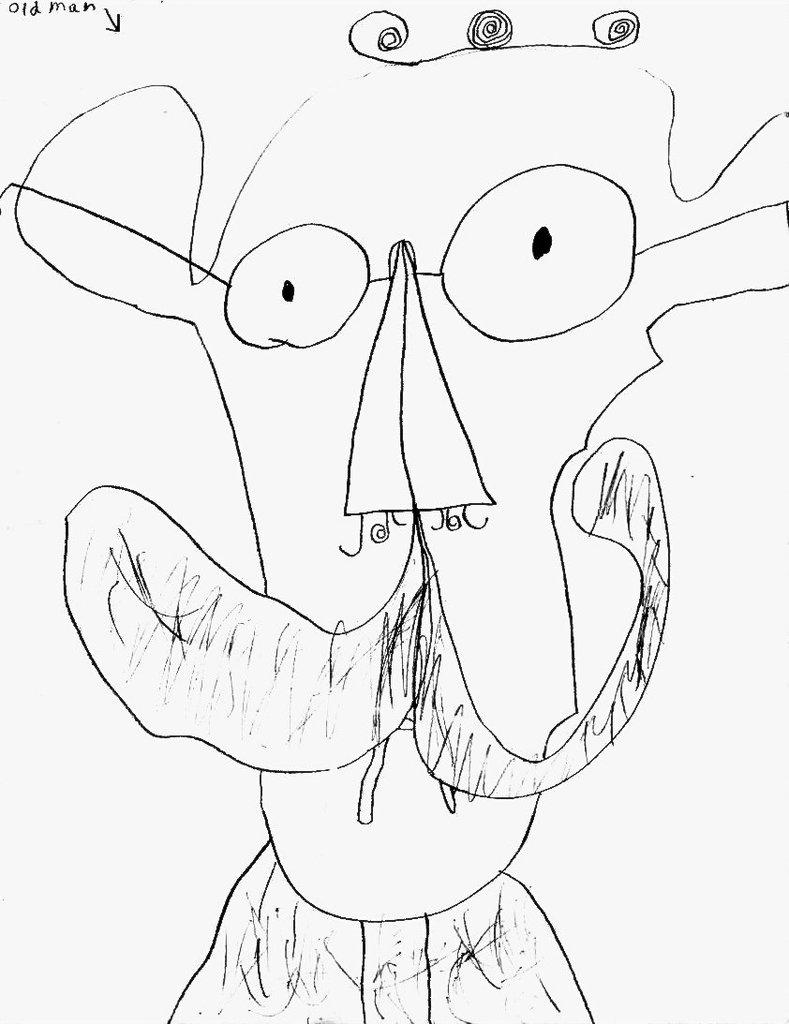What is the main subject of the image? There is a drawing of a person in the image. Where is the drawing located in the image? The drawing is in the center of the image. What type of beam can be seen supporting the pig in the image? There is no beam or pig present in the image; it only features a drawing of a person. 